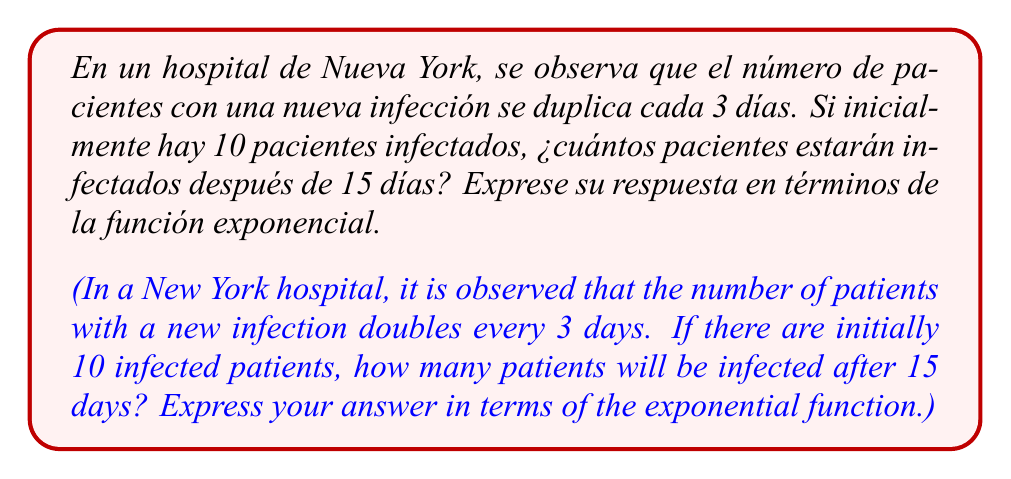Give your solution to this math problem. Para resolver este problema, utilizaremos el modelo de crecimiento exponencial. La fórmula general es:

$$N(t) = N_0 \cdot e^{rt}$$

Donde:
$N(t)$ es el número de infectados en el tiempo $t$
$N_0$ es el número inicial de infectados
$r$ es la tasa de crecimiento
$t$ es el tiempo transcurrido

Primero, necesitamos encontrar la tasa de crecimiento $r$. Sabemos que la población se duplica cada 3 días, por lo que:

$$2 = e^{3r}$$

Tomando el logaritmo natural de ambos lados:

$$\ln(2) = 3r$$

$$r = \frac{\ln(2)}{3} \approx 0.2310$$

Ahora, podemos aplicar la fórmula con los datos dados:

$N_0 = 10$ (pacientes iniciales)
$t = 15$ (días)
$r = \frac{\ln(2)}{3}$

$$N(15) = 10 \cdot e^{\frac{\ln(2)}{3} \cdot 15}$$

Simplificando:

$$N(15) = 10 \cdot e^{5\ln(2)}$$

$$N(15) = 10 \cdot (e^{\ln(2)})^5$$

$$N(15) = 10 \cdot 2^5$$

$$N(15) = 10 \cdot 32 = 320$$
Answer: $N(15) = 10 \cdot e^{5\ln(2)} \approx 320$ pacientes 